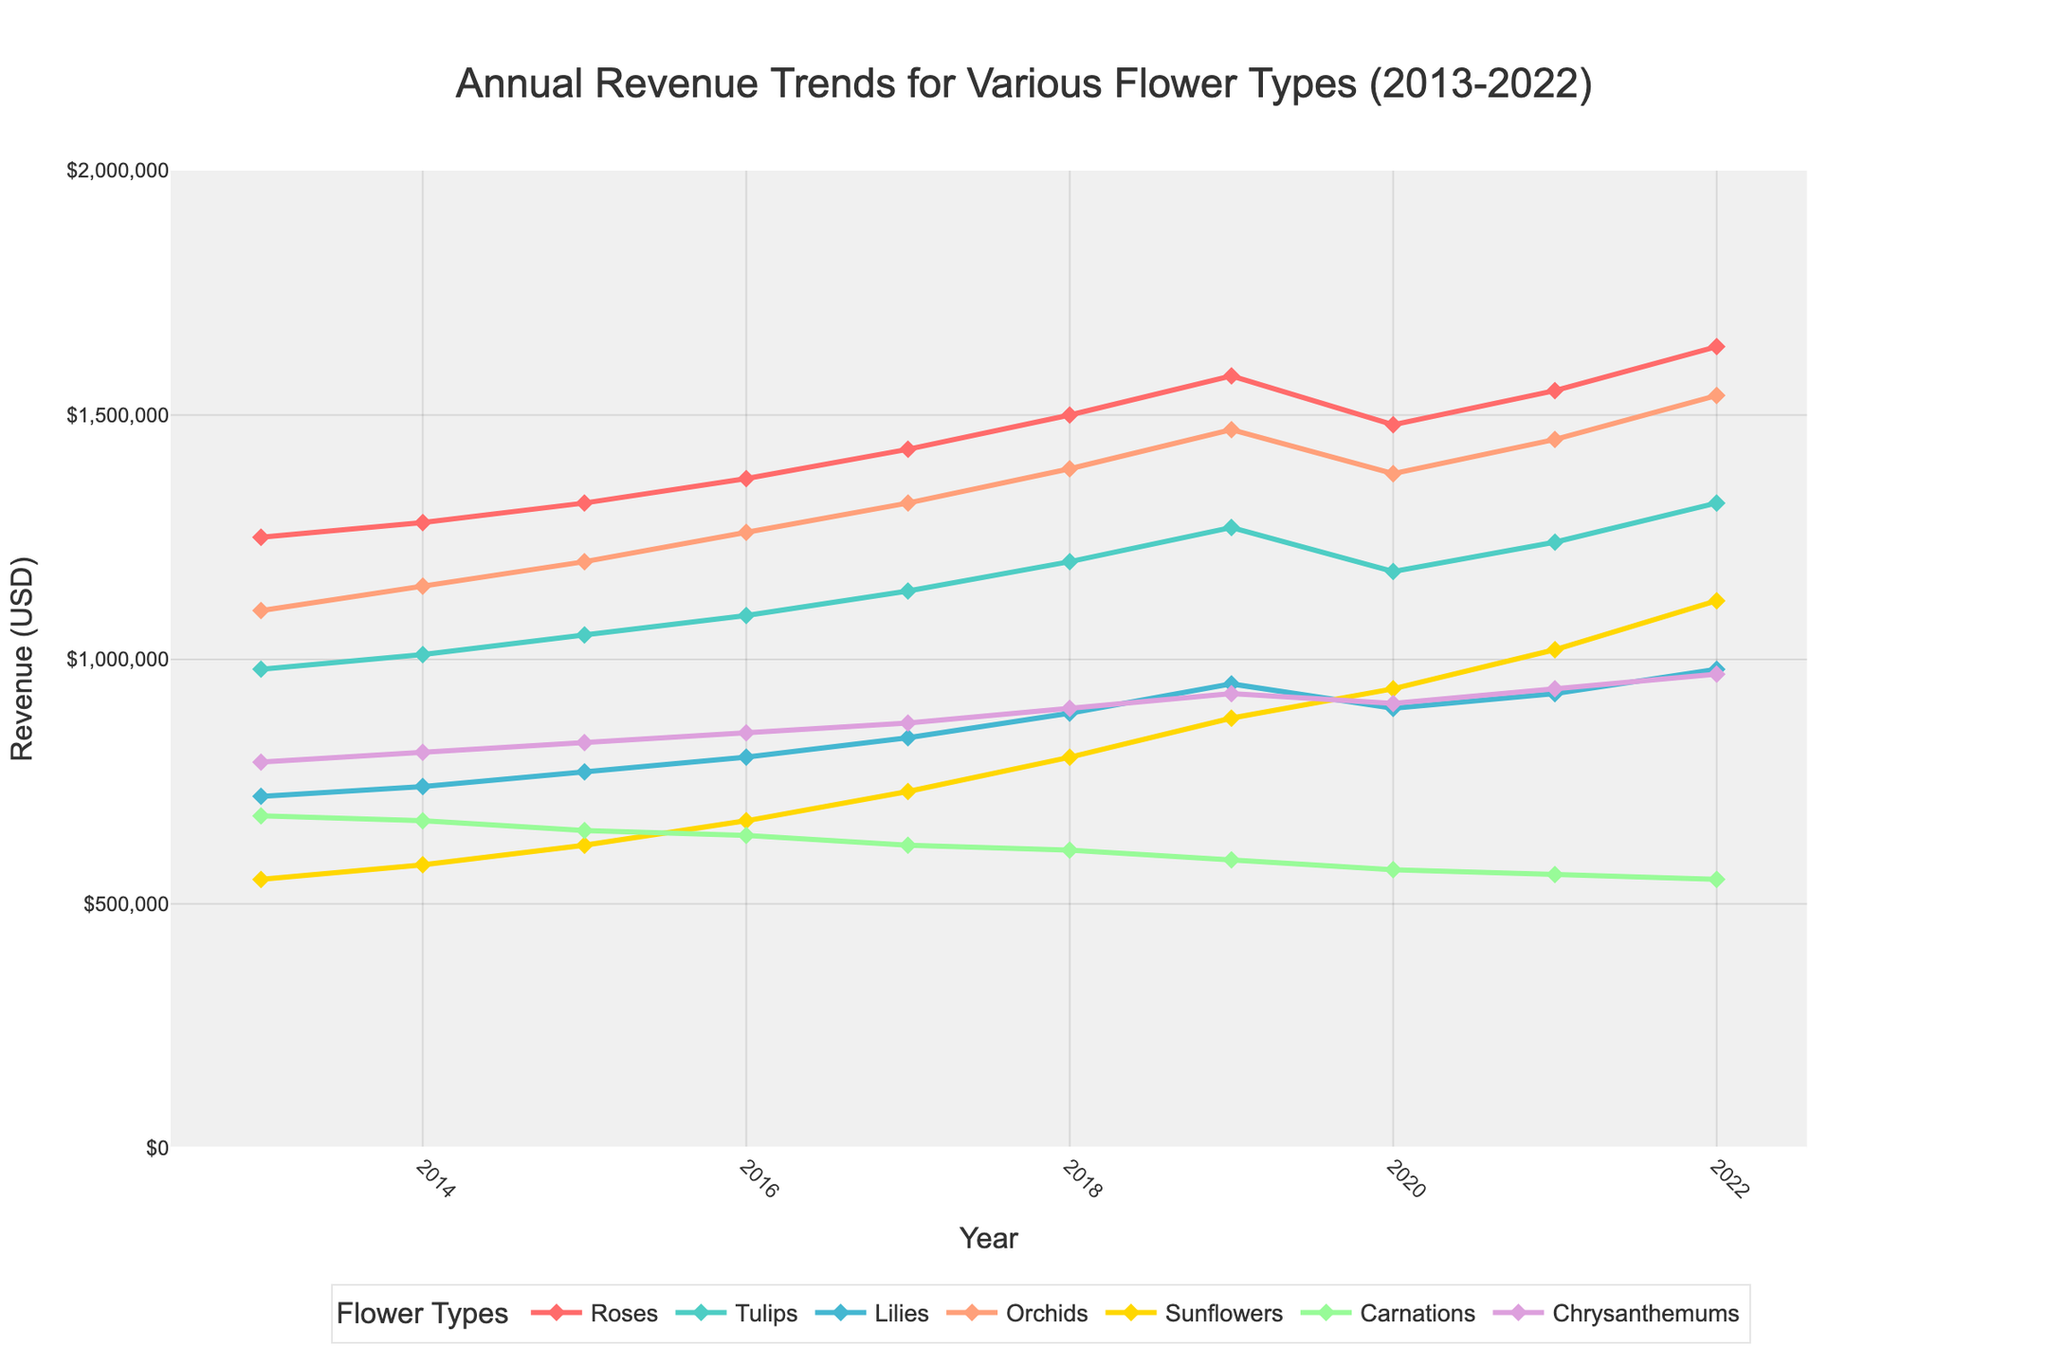Which flower type shows the highest annual revenue increase from 2013 to 2022? To determine which flower type shows the highest annual revenue increase, subtract the 2013 revenue from the 2022 revenue for each flower type and compare the results. Roses: 1,640,000 - 1,250,000 = 390,000, Tulips: 1,320,000 - 980,000 = 340,000, Lilies: 980,000 - 720,000 = 260,000, Orchids: 1,540,000 - 1,100,000 = 440,000, Sunflowers: 1,120,000 - 550,000 = 570,000, Carnations: 550,000 - 680,000 = -130,000, Chrysanthemums: 970,000 - 790,000 = 180,000. Therefore, Sunflowers show the highest increase of 570,000.
Answer: Sunflowers Which year did Tulips revenue surpass 1,000,000 USD for the first time? To find when Tulips' revenue first surpassed 1,000,000 USD, look at the yearly revenue figures for Tulips. The revenue for Tulips is 980,000 in 2013, 1,010,000 in 2014. Therefore, 2014 is the first year Tulips' revenue exceeded 1,000,000 USD.
Answer: 2014 Which flower type had the least growth in revenue from 2013 to 2022? First, compute the growth for each flower type from 2013 to 2022: Roses: 1,640,000 - 1,250,000, Tulips: 1,320,000 - 980,000, Lilies: 980,000 - 720,000, Orchids: 1,540,000 - 1,100,000, Sunflowers: 1,120,000 - 550,000, Carnations: 550,000 - 680,000, Chrysanthemums: 970,000 - 790,000. Carnations show a decrease from 680,000 to 550,000, which is the least growth since it is negative.
Answer: Carnations In which year did Orchids see its maximum revenue? From the chart, identify the year with the highest revenue for Orchids. The revenues are 1,100,000 (2013), 1,150,000 (2014), 1,200,000 (2015), 1,260,000 (2016), 1,320,000 (2017), 1,390,000 (2018), 1,470,000 (2019), 1,380,000 (2020), 1,450,000 (2021), and 1,540,000 (2022). The maximum revenue of 1,540,000 occurs in 2022.
Answer: 2022 Which flower types experienced a revenue drop in 2020 compared to 2019? To find which flower types had a decrease in 2020 compared to 2019, compare the revenue figures for these years. Roses: 1,580,000 (2019) to 1,480,000 (2020), Tulips: 1,270,000  (2019) to 1,180,000 (2020), Lilies: 950,000 (2019) to 900,000 (2020), Orchids: 1,470,000 (2019) to 1,380,000 (2020), Sunflowers: 880,000 (2019) to 940,000 (2020), Carnations: 590,000 (2019) to 570,000 (2020), Chrysanthemums: 930,000 (2019) to 910,000 (2020). All flowers experienced a drop except Sunflowers.
Answer: Roses, Tulips, Lilies, Orchids, Carnations, Chrysanthemums What is the total combined revenue for Roses and Orchids in 2015? Add the revenue for Roses and Orchids together in 2015. Roses: 1,320,000, Orchids: 1,200,000. The total combined revenue is 1,320,000 + 1,200,000 = 2,520,000.
Answer: 2,520,000 Which flower type has the most stable revenue trend over the decade? To determine the most stable revenue trend, look for the flower type with the least fluctuation over the decade. Roses, Tulips, and Orchids show relatively steady upward trends without significant drops, but Tulips have the most consistent small increases yearly and least variation.
Answer: Tulips In which year did Sunflowers outperform Carnations in revenue for the first time? Compare the yearly revenues of Sunflowers and Carnations until Sunflowers exceed Carnations for the first time. In 2017, Sunflowers (730,000) surpassed Carnations (620,000) in revenue.
Answer: 2017 Between 2016 and 2021, which flower type had the highest average annual revenue? Calculate the average revenue for each flower type from 2016 to 2021 and compare. Average (Roses: [1,370,000+1,430,000+1,500,000+1,580,000+1,480,000+1,550,000]); Tulips: [1,090,000+1,140,000+1,200,000+1,270,000+1,180,000+1,240,000]); Lilies: [800,000+840,000+890,000+950,000+900,000+930,000]); etc., Orchids have the highest average revenue.
Answer: Orchids 